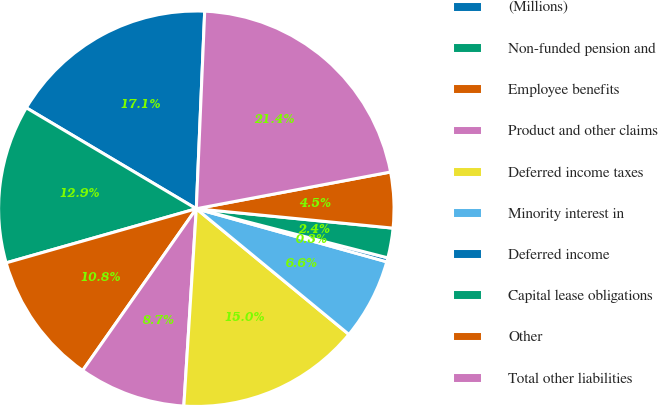Convert chart. <chart><loc_0><loc_0><loc_500><loc_500><pie_chart><fcel>(Millions)<fcel>Non-funded pension and<fcel>Employee benefits<fcel>Product and other claims<fcel>Deferred income taxes<fcel>Minority interest in<fcel>Deferred income<fcel>Capital lease obligations<fcel>Other<fcel>Total other liabilities<nl><fcel>17.15%<fcel>12.94%<fcel>10.84%<fcel>8.74%<fcel>15.04%<fcel>6.64%<fcel>0.33%<fcel>2.43%<fcel>4.54%<fcel>21.35%<nl></chart> 